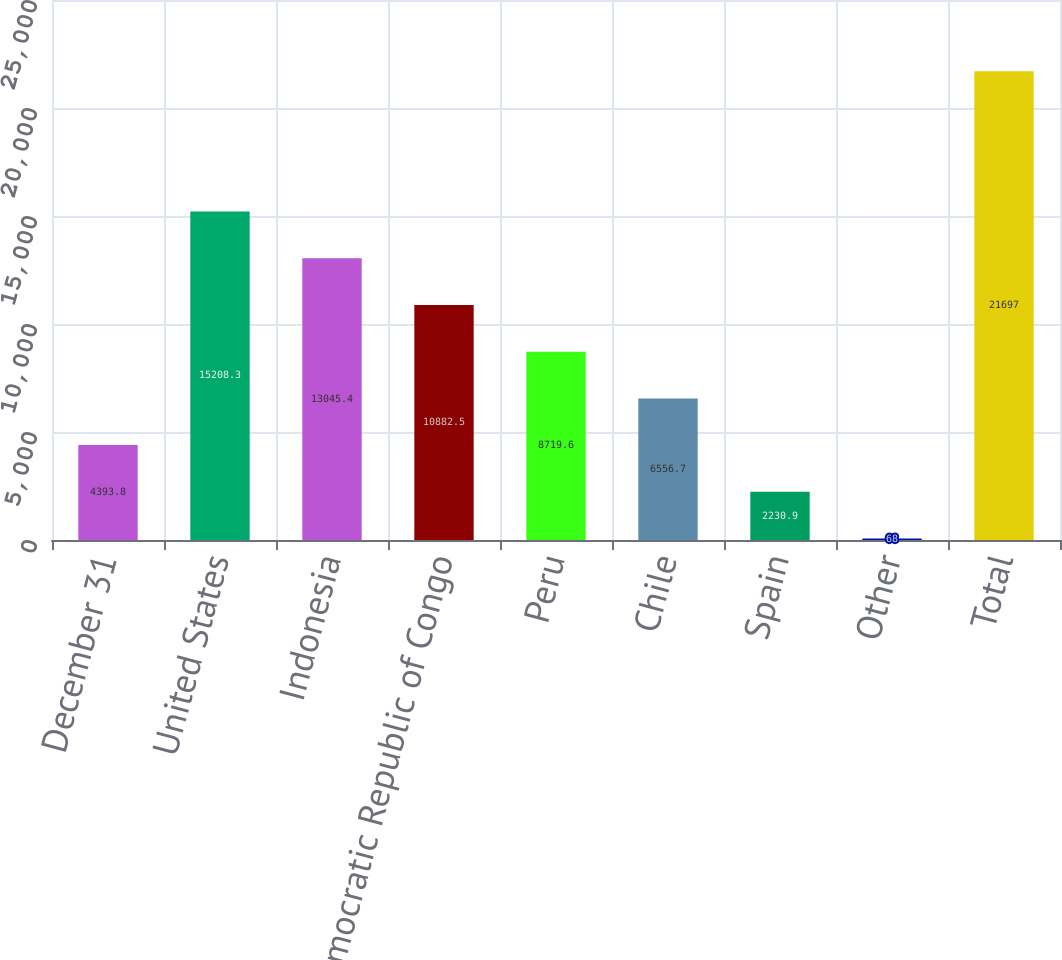Convert chart. <chart><loc_0><loc_0><loc_500><loc_500><bar_chart><fcel>December 31<fcel>United States<fcel>Indonesia<fcel>Democratic Republic of Congo<fcel>Peru<fcel>Chile<fcel>Spain<fcel>Other<fcel>Total<nl><fcel>4393.8<fcel>15208.3<fcel>13045.4<fcel>10882.5<fcel>8719.6<fcel>6556.7<fcel>2230.9<fcel>68<fcel>21697<nl></chart> 